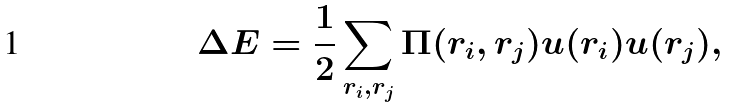Convert formula to latex. <formula><loc_0><loc_0><loc_500><loc_500>\Delta E = \frac { 1 } { 2 } \sum _ { { r } _ { i } , { r } _ { j } } \Pi ( { r } _ { i } , { r } _ { j } ) u ( { r } _ { i } ) u ( { r } _ { j } ) ,</formula> 